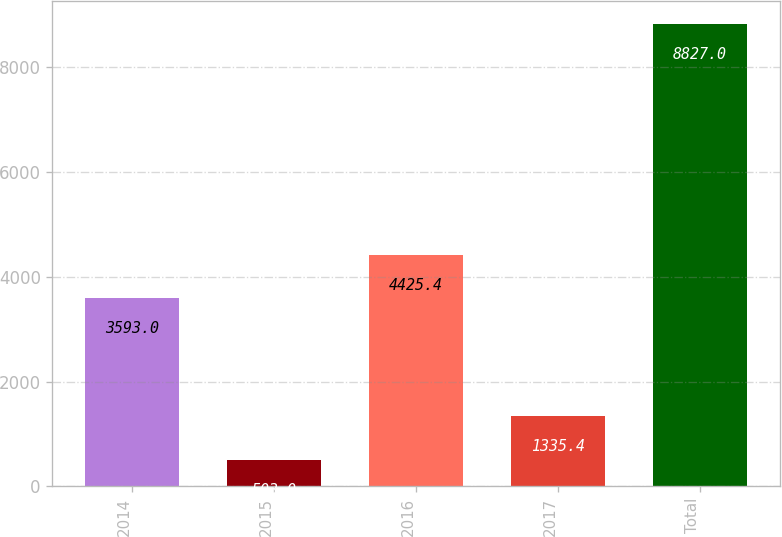Convert chart to OTSL. <chart><loc_0><loc_0><loc_500><loc_500><bar_chart><fcel>2014<fcel>2015<fcel>2016<fcel>2017<fcel>Total<nl><fcel>3593<fcel>503<fcel>4425.4<fcel>1335.4<fcel>8827<nl></chart> 